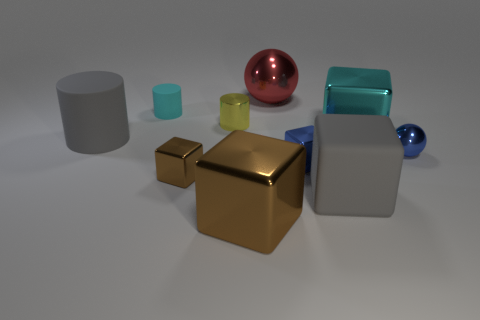There is a large object that is the same color as the small matte object; what is its shape?
Provide a succinct answer. Cube. There is a rubber cylinder that is the same color as the rubber block; what size is it?
Your answer should be very brief. Large. How many other objects are there of the same shape as the small cyan rubber thing?
Make the answer very short. 2. The red metallic ball has what size?
Ensure brevity in your answer.  Large. What number of things are big red things or tiny yellow metal cylinders?
Your answer should be very brief. 2. How big is the metallic sphere to the left of the large gray rubber block?
Ensure brevity in your answer.  Large. There is a small thing that is to the right of the cyan matte cylinder and behind the cyan metallic object; what color is it?
Give a very brief answer. Yellow. Does the gray thing left of the small yellow cylinder have the same material as the large brown block?
Offer a terse response. No. There is a big rubber cylinder; is its color the same as the large matte thing that is right of the gray rubber cylinder?
Offer a terse response. Yes. There is a yellow metal thing; are there any rubber objects to the left of it?
Provide a short and direct response. Yes. 